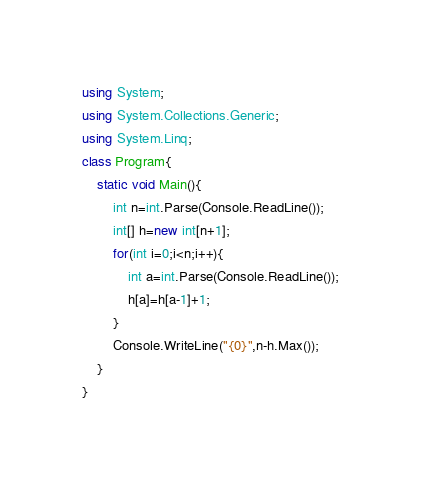Convert code to text. <code><loc_0><loc_0><loc_500><loc_500><_C#_>using System;
using System.Collections.Generic;
using System.Linq;
class Program{
	static void Main(){
		int n=int.Parse(Console.ReadLine());
		int[] h=new int[n+1];
		for(int i=0;i<n;i++){
			int a=int.Parse(Console.ReadLine());
			h[a]=h[a-1]+1;
		}
		Console.WriteLine("{0}",n-h.Max());
	}
}</code> 